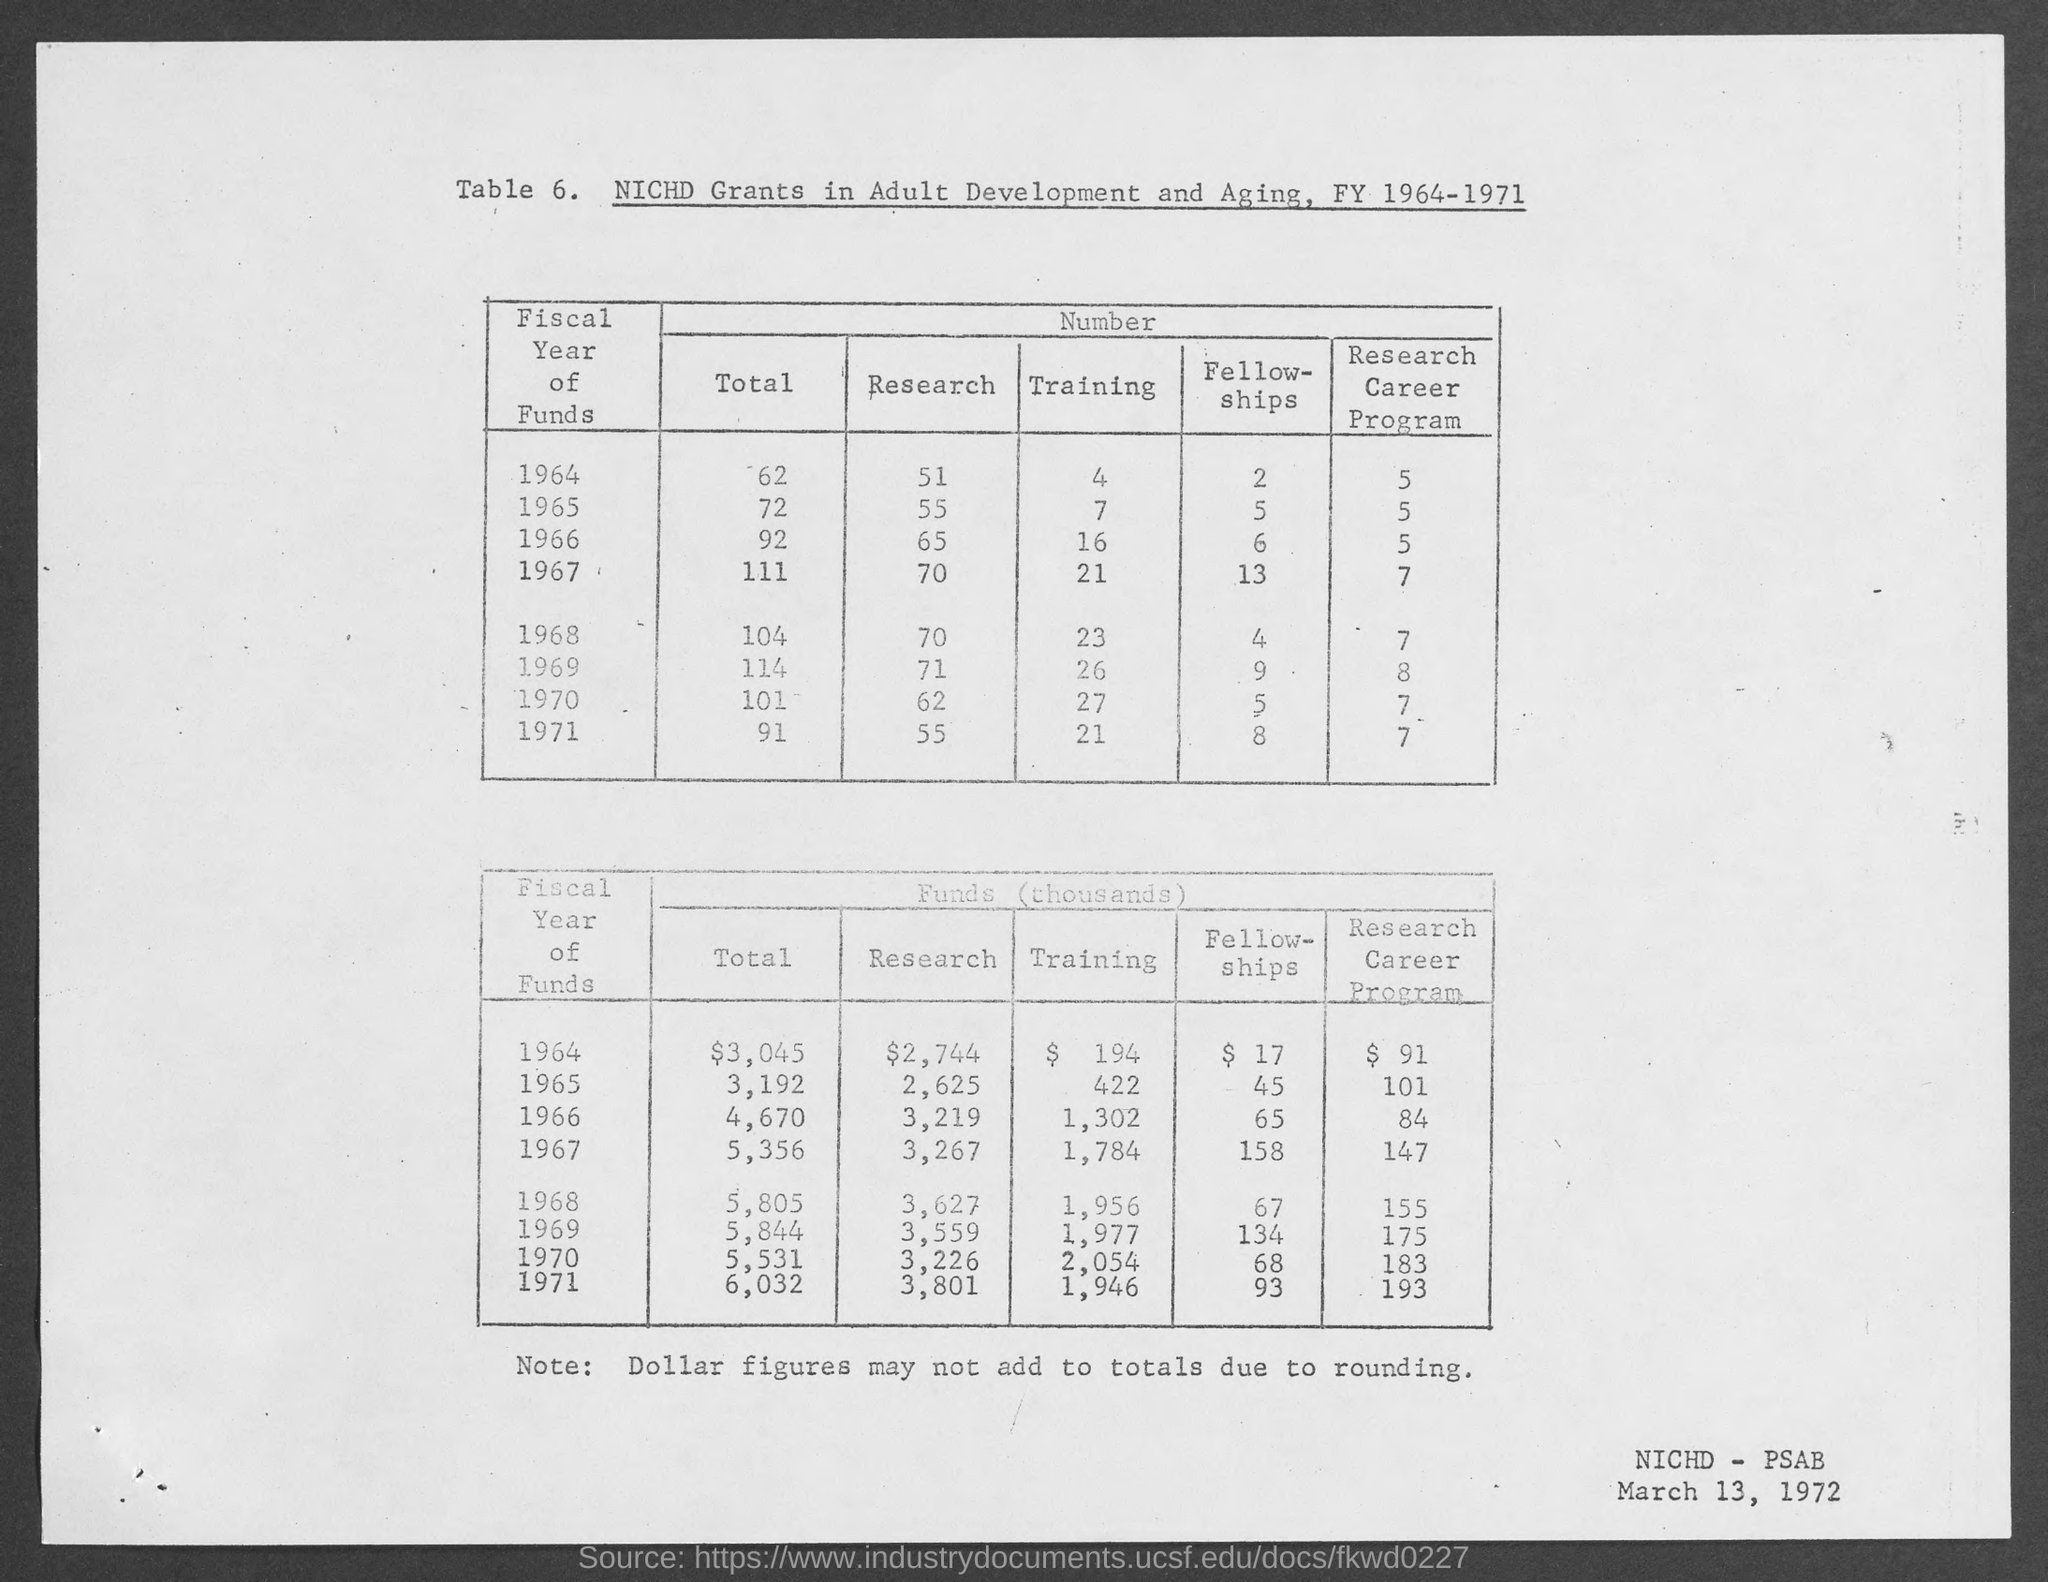Point out several critical features in this image. In the year 1965, the total value of funds was 3,192. The total value of funds in the year 1964 was $3,045. According to the given table, the amount of fund for research in the year 1965 was 2,625. In the year 1971, the total value of funds was 6,032. In the year 1968, the total value of funds was 5,805. 